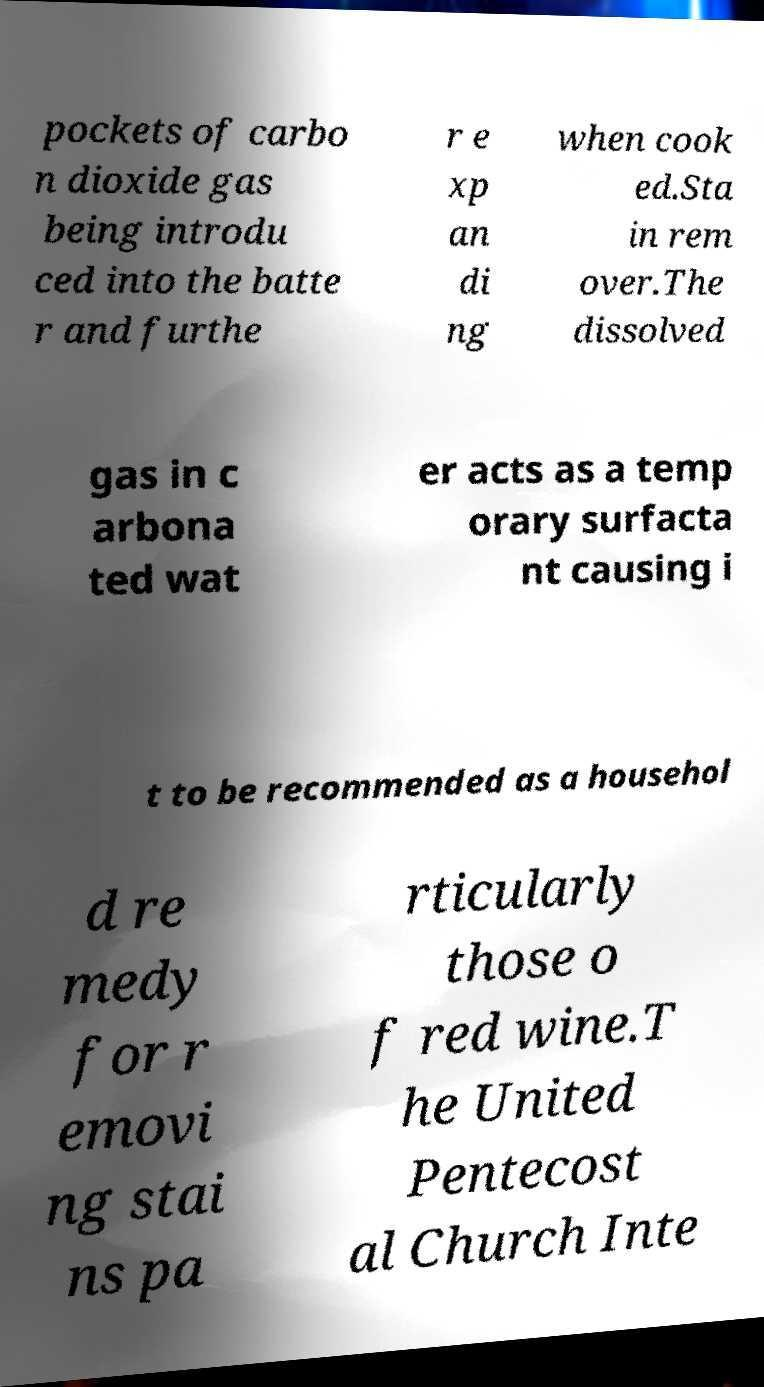What messages or text are displayed in this image? I need them in a readable, typed format. pockets of carbo n dioxide gas being introdu ced into the batte r and furthe r e xp an di ng when cook ed.Sta in rem over.The dissolved gas in c arbona ted wat er acts as a temp orary surfacta nt causing i t to be recommended as a househol d re medy for r emovi ng stai ns pa rticularly those o f red wine.T he United Pentecost al Church Inte 